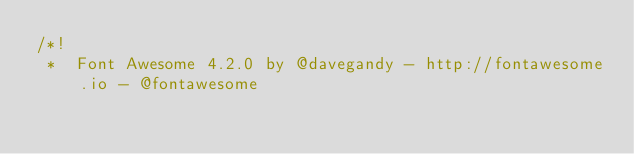<code> <loc_0><loc_0><loc_500><loc_500><_CSS_>/*!
 *  Font Awesome 4.2.0 by @davegandy - http://fontawesome.io - @fontawesome</code> 